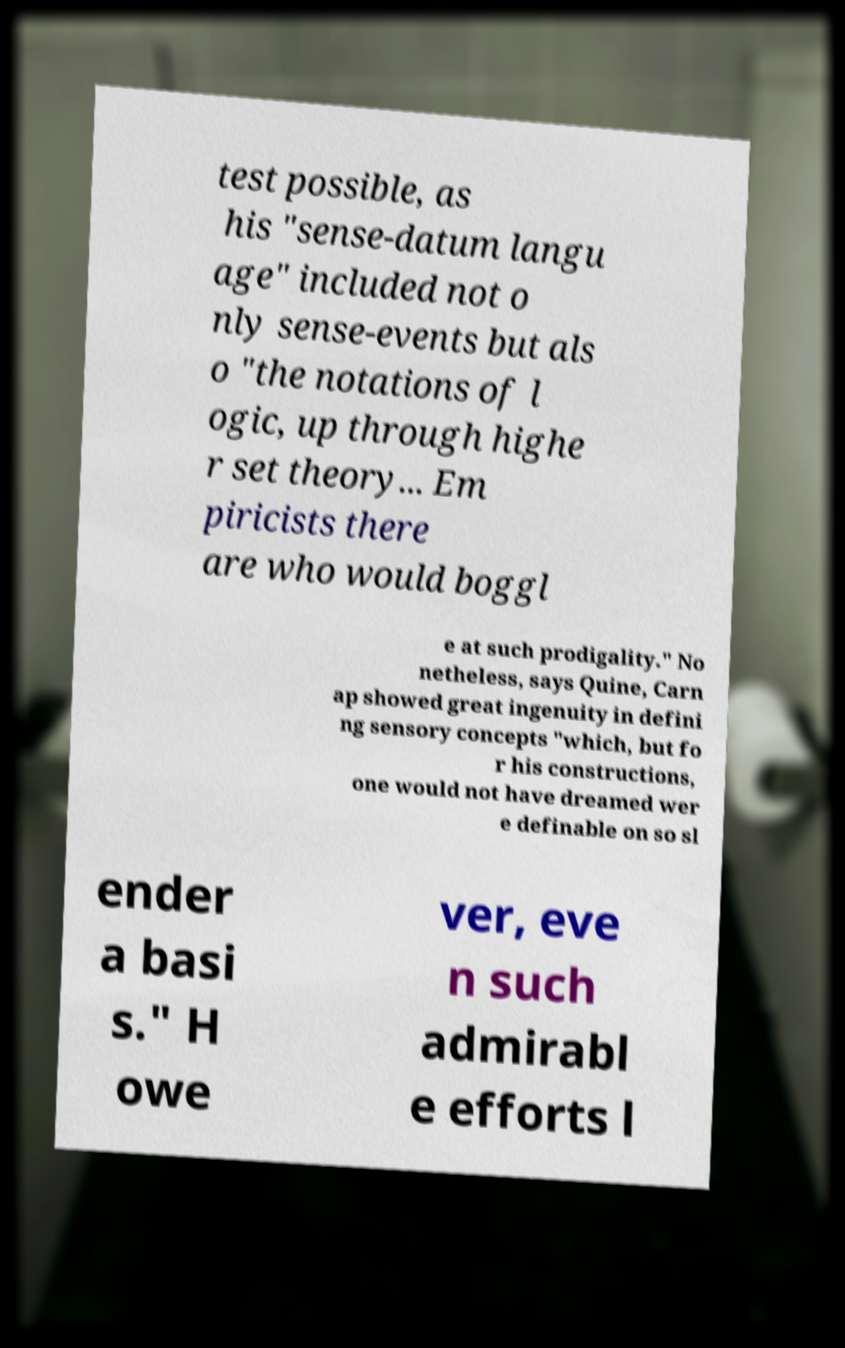Please read and relay the text visible in this image. What does it say? test possible, as his "sense-datum langu age" included not o nly sense-events but als o "the notations of l ogic, up through highe r set theory... Em piricists there are who would boggl e at such prodigality." No netheless, says Quine, Carn ap showed great ingenuity in defini ng sensory concepts "which, but fo r his constructions, one would not have dreamed wer e definable on so sl ender a basi s." H owe ver, eve n such admirabl e efforts l 